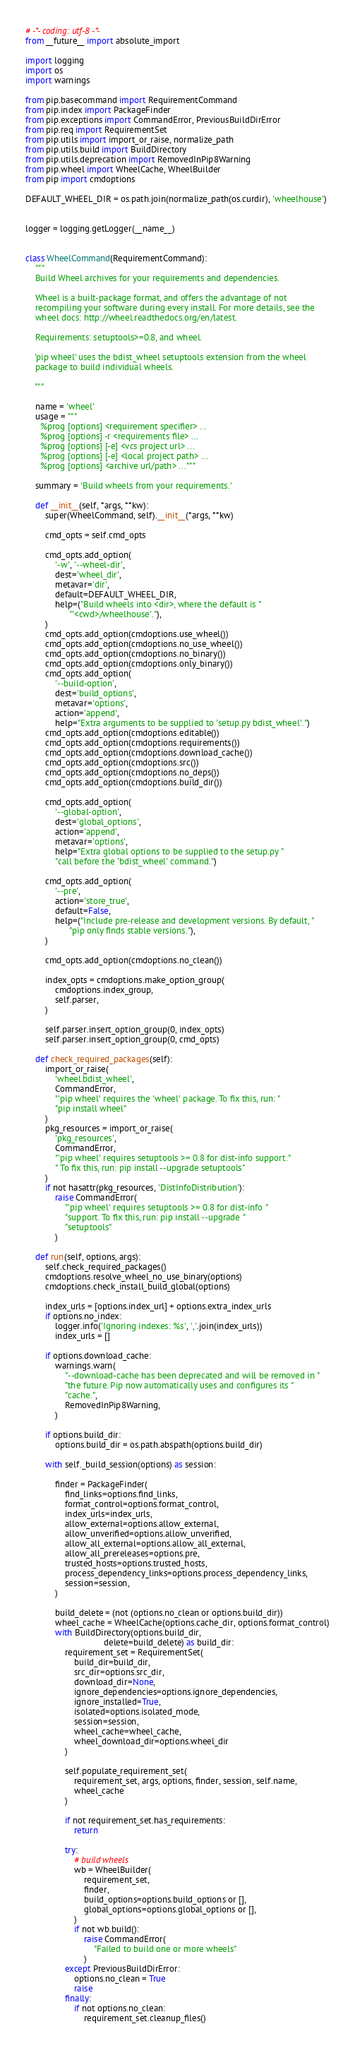<code> <loc_0><loc_0><loc_500><loc_500><_Python_># -*- coding: utf-8 -*-
from __future__ import absolute_import

import logging
import os
import warnings

from pip.basecommand import RequirementCommand
from pip.index import PackageFinder
from pip.exceptions import CommandError, PreviousBuildDirError
from pip.req import RequirementSet
from pip.utils import import_or_raise, normalize_path
from pip.utils.build import BuildDirectory
from pip.utils.deprecation import RemovedInPip8Warning
from pip.wheel import WheelCache, WheelBuilder
from pip import cmdoptions

DEFAULT_WHEEL_DIR = os.path.join(normalize_path(os.curdir), 'wheelhouse')


logger = logging.getLogger(__name__)


class WheelCommand(RequirementCommand):
    """
    Build Wheel archives for your requirements and dependencies.

    Wheel is a built-package format, and offers the advantage of not
    recompiling your software during every install. For more details, see the
    wheel docs: http://wheel.readthedocs.org/en/latest.

    Requirements: setuptools>=0.8, and wheel.

    'pip wheel' uses the bdist_wheel setuptools extension from the wheel
    package to build individual wheels.

    """

    name = 'wheel'
    usage = """
      %prog [options] <requirement specifier> ...
      %prog [options] -r <requirements file> ...
      %prog [options] [-e] <vcs project url> ...
      %prog [options] [-e] <local project path> ...
      %prog [options] <archive url/path> ..."""

    summary = 'Build wheels from your requirements.'

    def __init__(self, *args, **kw):
        super(WheelCommand, self).__init__(*args, **kw)

        cmd_opts = self.cmd_opts

        cmd_opts.add_option(
            '-w', '--wheel-dir',
            dest='wheel_dir',
            metavar='dir',
            default=DEFAULT_WHEEL_DIR,
            help=("Build wheels into <dir>, where the default is "
                  "'<cwd>/wheelhouse'."),
        )
        cmd_opts.add_option(cmdoptions.use_wheel())
        cmd_opts.add_option(cmdoptions.no_use_wheel())
        cmd_opts.add_option(cmdoptions.no_binary())
        cmd_opts.add_option(cmdoptions.only_binary())
        cmd_opts.add_option(
            '--build-option',
            dest='build_options',
            metavar='options',
            action='append',
            help="Extra arguments to be supplied to 'setup.py bdist_wheel'.")
        cmd_opts.add_option(cmdoptions.editable())
        cmd_opts.add_option(cmdoptions.requirements())
        cmd_opts.add_option(cmdoptions.download_cache())
        cmd_opts.add_option(cmdoptions.src())
        cmd_opts.add_option(cmdoptions.no_deps())
        cmd_opts.add_option(cmdoptions.build_dir())

        cmd_opts.add_option(
            '--global-option',
            dest='global_options',
            action='append',
            metavar='options',
            help="Extra global options to be supplied to the setup.py "
            "call before the 'bdist_wheel' command.")

        cmd_opts.add_option(
            '--pre',
            action='store_true',
            default=False,
            help=("Include pre-release and development versions. By default, "
                  "pip only finds stable versions."),
        )

        cmd_opts.add_option(cmdoptions.no_clean())

        index_opts = cmdoptions.make_option_group(
            cmdoptions.index_group,
            self.parser,
        )

        self.parser.insert_option_group(0, index_opts)
        self.parser.insert_option_group(0, cmd_opts)

    def check_required_packages(self):
        import_or_raise(
            'wheel.bdist_wheel',
            CommandError,
            "'pip wheel' requires the 'wheel' package. To fix this, run: "
            "pip install wheel"
        )
        pkg_resources = import_or_raise(
            'pkg_resources',
            CommandError,
            "'pip wheel' requires setuptools >= 0.8 for dist-info support."
            " To fix this, run: pip install --upgrade setuptools"
        )
        if not hasattr(pkg_resources, 'DistInfoDistribution'):
            raise CommandError(
                "'pip wheel' requires setuptools >= 0.8 for dist-info "
                "support. To fix this, run: pip install --upgrade "
                "setuptools"
            )

    def run(self, options, args):
        self.check_required_packages()
        cmdoptions.resolve_wheel_no_use_binary(options)
        cmdoptions.check_install_build_global(options)

        index_urls = [options.index_url] + options.extra_index_urls
        if options.no_index:
            logger.info('Ignoring indexes: %s', ','.join(index_urls))
            index_urls = []

        if options.download_cache:
            warnings.warn(
                "--download-cache has been deprecated and will be removed in "
                "the future. Pip now automatically uses and configures its "
                "cache.",
                RemovedInPip8Warning,
            )

        if options.build_dir:
            options.build_dir = os.path.abspath(options.build_dir)

        with self._build_session(options) as session:

            finder = PackageFinder(
                find_links=options.find_links,
                format_control=options.format_control,
                index_urls=index_urls,
                allow_external=options.allow_external,
                allow_unverified=options.allow_unverified,
                allow_all_external=options.allow_all_external,
                allow_all_prereleases=options.pre,
                trusted_hosts=options.trusted_hosts,
                process_dependency_links=options.process_dependency_links,
                session=session,
            )

            build_delete = (not (options.no_clean or options.build_dir))
            wheel_cache = WheelCache(options.cache_dir, options.format_control)
            with BuildDirectory(options.build_dir,
                                delete=build_delete) as build_dir:
                requirement_set = RequirementSet(
                    build_dir=build_dir,
                    src_dir=options.src_dir,
                    download_dir=None,
                    ignore_dependencies=options.ignore_dependencies,
                    ignore_installed=True,
                    isolated=options.isolated_mode,
                    session=session,
                    wheel_cache=wheel_cache,
                    wheel_download_dir=options.wheel_dir
                )

                self.populate_requirement_set(
                    requirement_set, args, options, finder, session, self.name,
                    wheel_cache
                )

                if not requirement_set.has_requirements:
                    return

                try:
                    # build wheels
                    wb = WheelBuilder(
                        requirement_set,
                        finder,
                        build_options=options.build_options or [],
                        global_options=options.global_options or [],
                    )
                    if not wb.build():
                        raise CommandError(
                            "Failed to build one or more wheels"
                        )
                except PreviousBuildDirError:
                    options.no_clean = True
                    raise
                finally:
                    if not options.no_clean:
                        requirement_set.cleanup_files()
</code> 